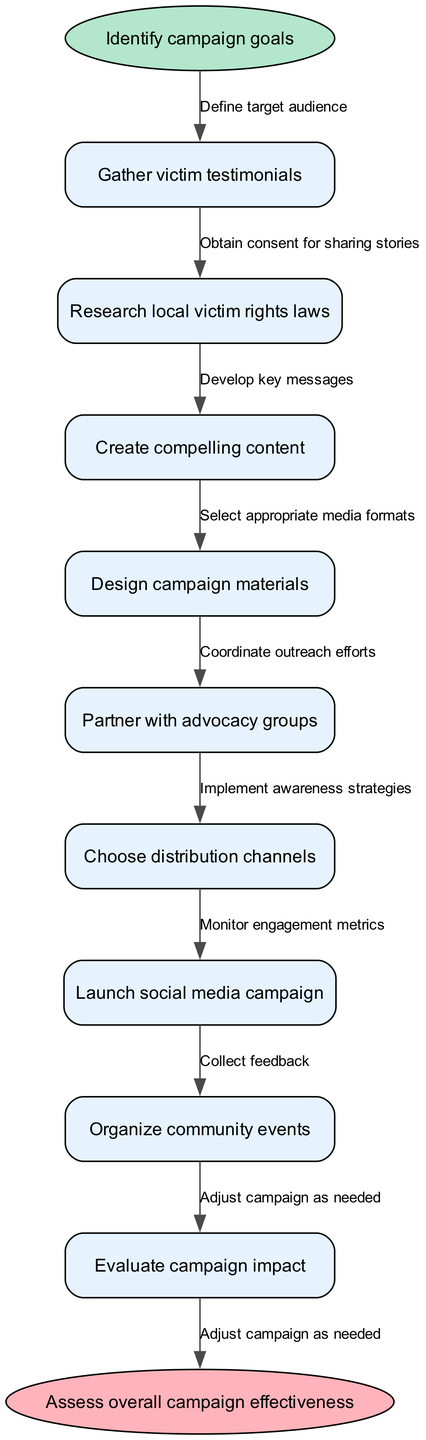What is the starting point of the campaign? The starting point as indicated in the diagram is labeled "Identify campaign goals." This can be found at the top of the flow chart, showing where the campaign initiates.
Answer: Identify campaign goals What is the endpoint of the campaign process? The endpoint is marked as "Assess overall campaign effectiveness." This position is found at the bottom of the flow chart, indicating the final step after all actions have been taken.
Answer: Assess overall campaign effectiveness How many nodes are in the diagram? There are 10 nodes present in the flow chart, which includes the start node, 8 main process nodes, and the end node. By counting each of these, we arrive at the total number.
Answer: 10 What is the first node after the starting point? The first node following the starting point is "Gather victim testimonials," which is the immediate step to be taken after identifying campaign goals.
Answer: Gather victim testimonials Which node comes before "Design campaign materials"? The node that precedes "Design campaign materials" is "Create compelling content." By tracing the flow from the previous actions, we can confirm this relationship.
Answer: Create compelling content How many edges connect the nodes? There are 9 edges connecting the nodes throughout the flowchart. Each edge represents a step or relationship between consecutive nodes, leading from the start to the end.
Answer: 9 What is the relation between "Partner with advocacy groups" and "Choose distribution channels"? The relationship is that "Partner with advocacy groups" comes before "Choose distribution channels" in the flowchart, indicating that partnerships are formed before deciding on distribution methods.
Answer: Partner with advocacy groups What needs to be done after "Launch social media campaign"? After "Launch social media campaign," the next action is "Monitor engagement metrics," which involves tracking how well the campaign is being received online.
Answer: Monitor engagement metrics Which step follows directly after evaluating the campaign? The next step that follows is "Collect feedback," indicating that after assessing the campaign's effectiveness, organizers should gather input for further adjustments.
Answer: Collect feedback 